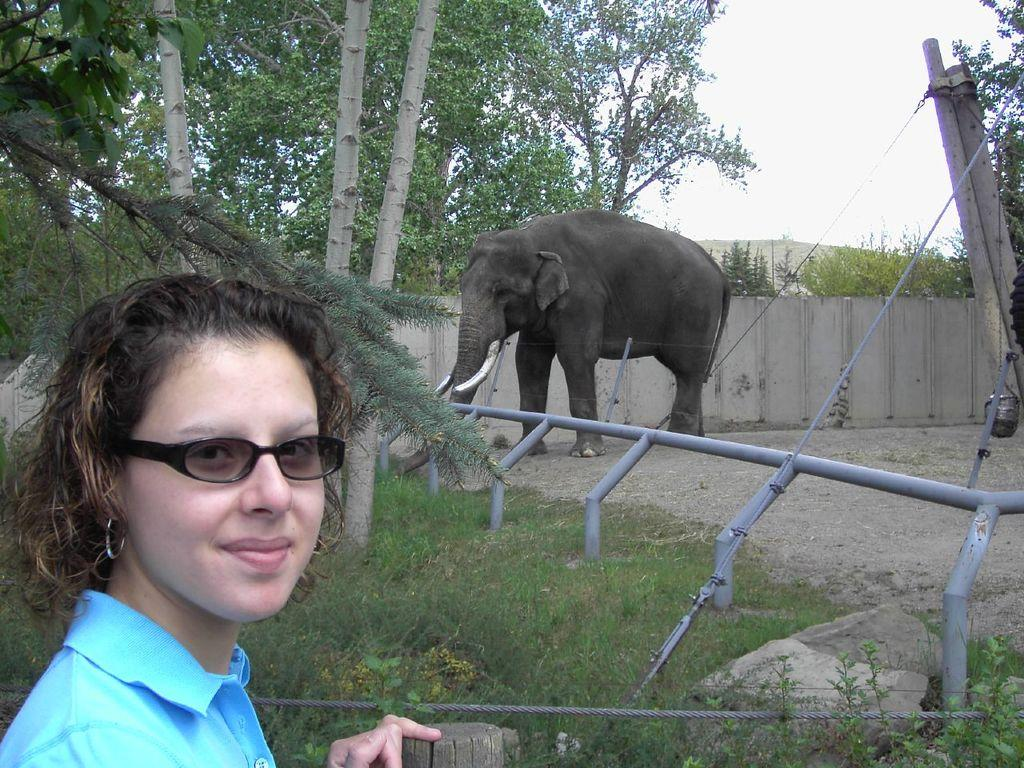Who is present in the image? There is a woman in the image. What is the woman's expression? The woman is smiling. What type of natural environment is visible in the image? There is grass and trees visible in the image. What animal is present in the image? There is an elephant in the image. How is the elephant contained in the image? The elephant is inside a wooden fence. What type of wax can be seen on the woman's lip in the image? There is no wax or lip visible in the image; it only features a woman, an elephant, and a wooden fence. 